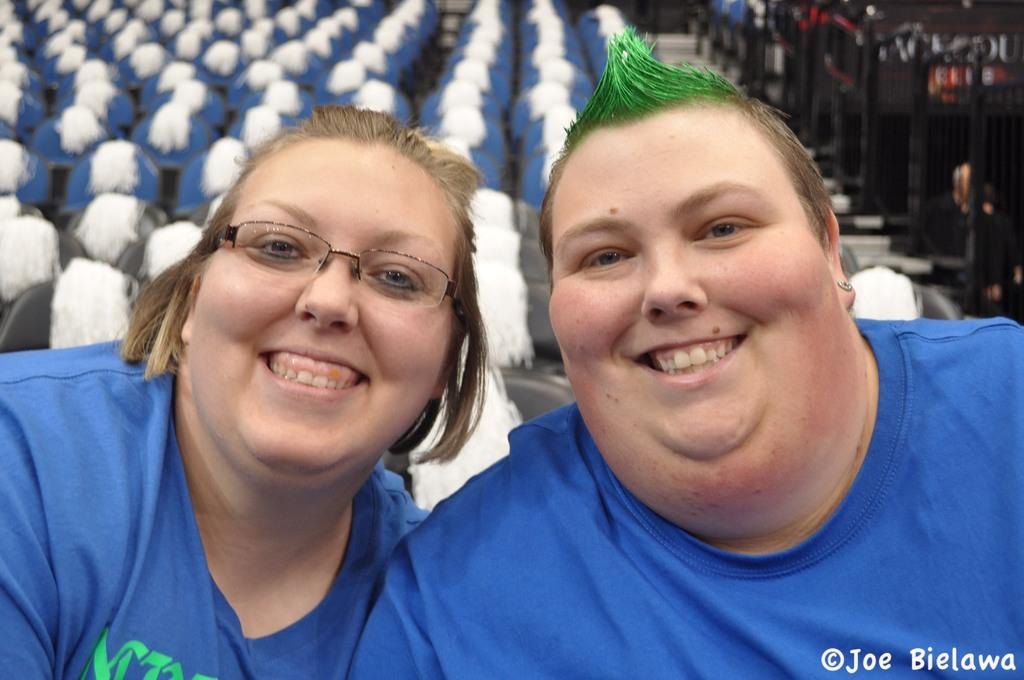How many people can be seen in the image? There are a few people in the image. What can be found in the background of the image? There are chairs in the background of the image. What color are the objects on the right side of the image? The objects on the right side of the image are black. Where is the text located in the image? The text is visible in the bottom right corner of the image. What type of paper is the person holding on their journey in the image? There is no person holding paper on a journey in the image. How much of the bit is visible in the image? There is no bit present in the image. 